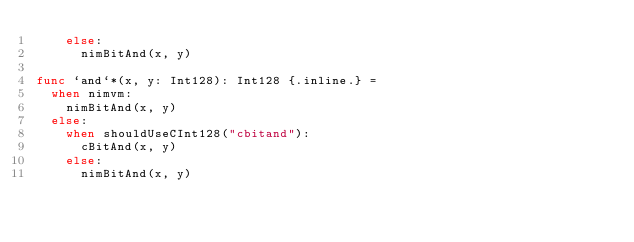<code> <loc_0><loc_0><loc_500><loc_500><_Nim_>    else:
      nimBitAnd(x, y)

func `and`*(x, y: Int128): Int128 {.inline.} =
  when nimvm:
    nimBitAnd(x, y)
  else:
    when shouldUseCInt128("cbitand"):
      cBitAnd(x, y)
    else:
      nimBitAnd(x, y)
</code> 